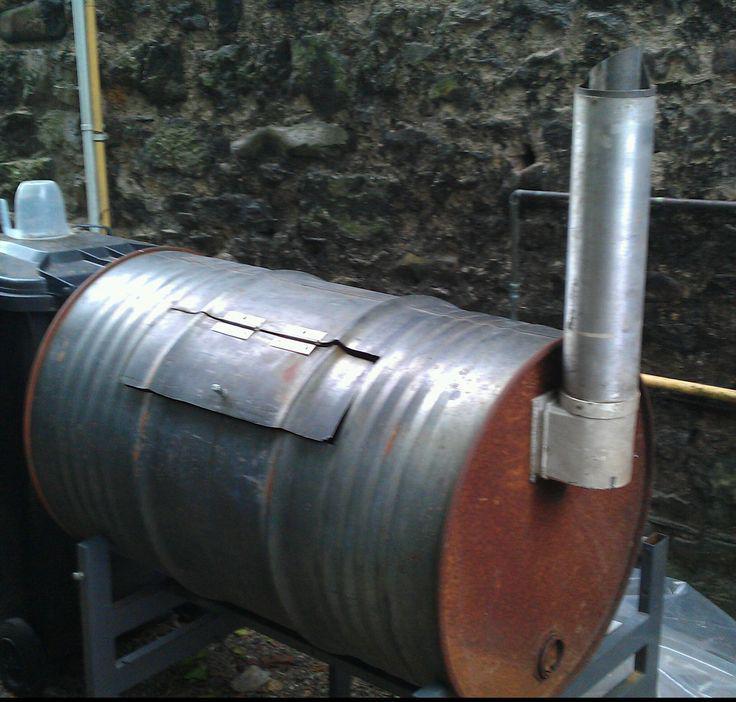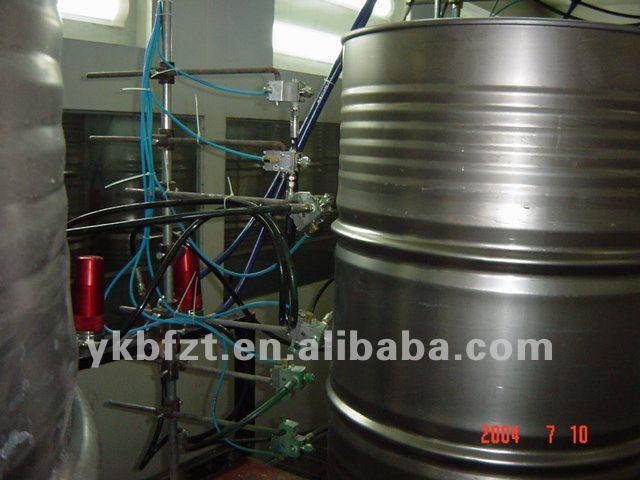The first image is the image on the left, the second image is the image on the right. Evaluate the accuracy of this statement regarding the images: "The left and right image contains the same amount of round metal barrels.". Is it true? Answer yes or no. Yes. 